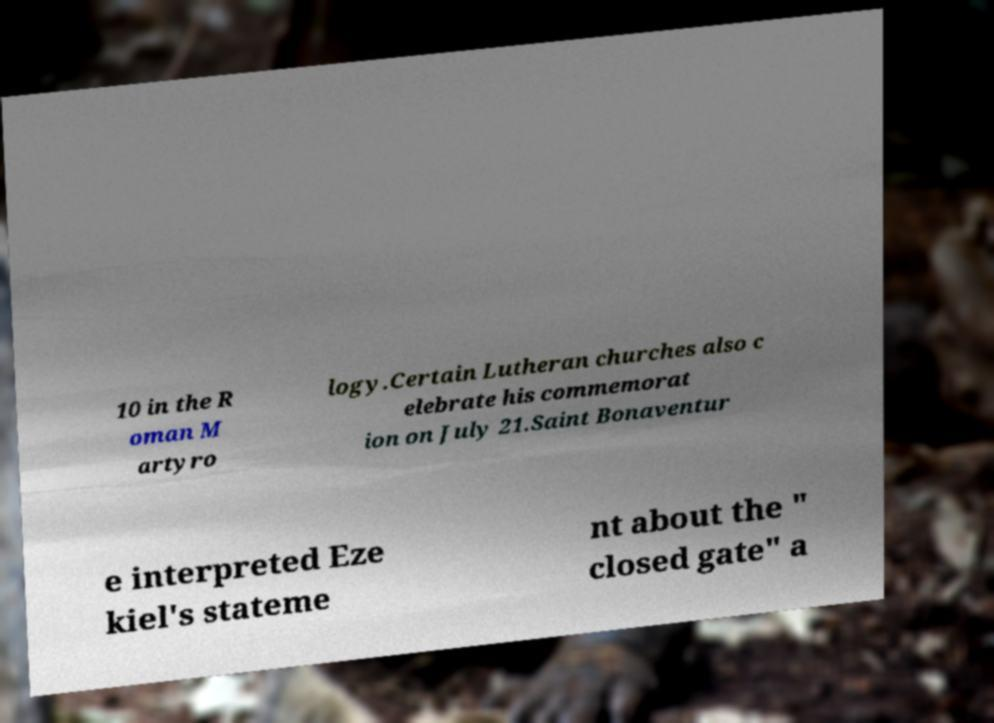Can you accurately transcribe the text from the provided image for me? 10 in the R oman M artyro logy.Certain Lutheran churches also c elebrate his commemorat ion on July 21.Saint Bonaventur e interpreted Eze kiel's stateme nt about the " closed gate" a 